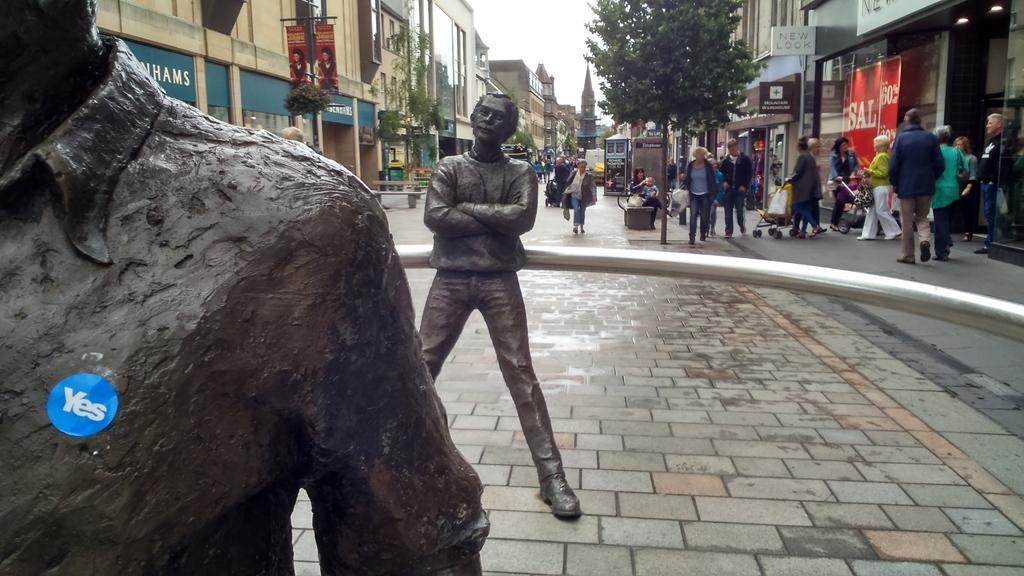Please provide a concise description of this image. In this image we can see that there are two statue one back side the other. In the background there is a road on which there are few people walking on it and there are some vehicles on it. There are buildings on either side of the road. On the footpath there are some people walking along with their trolleys. At the top there is sky. There are electric pole on the footpath. To the poles there are banners. 